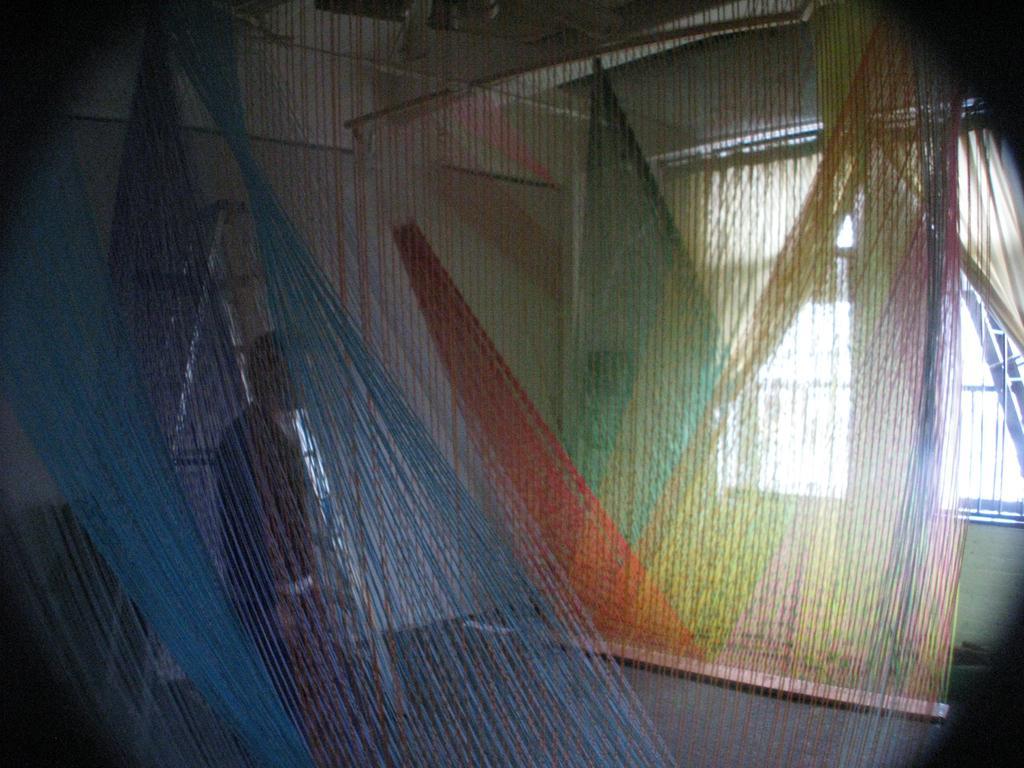Can you describe this image briefly? In this picture we can see curtains, on the right side there is a window, in the background we can see a person, a ladder and a wall. 